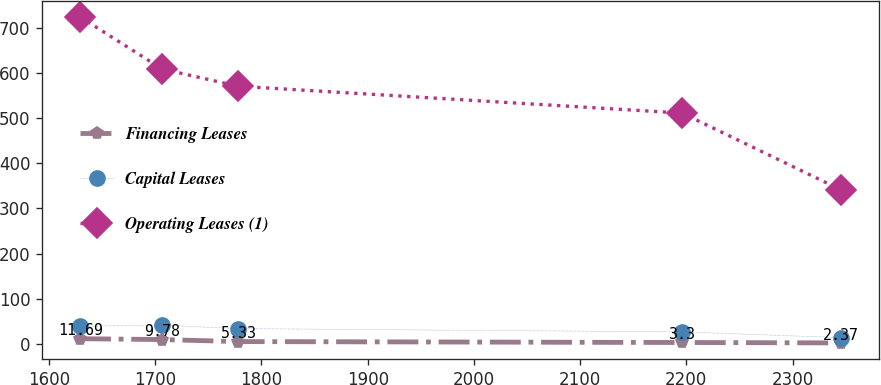Convert chart. <chart><loc_0><loc_0><loc_500><loc_500><line_chart><ecel><fcel>Financing Leases<fcel>Capital Leases<fcel>Operating Leases (1)<nl><fcel>1629.12<fcel>11.69<fcel>39.1<fcel>723.95<nl><fcel>1706.2<fcel>9.78<fcel>41.88<fcel>608.71<nl><fcel>1777.82<fcel>5.33<fcel>34.02<fcel>570.47<nl><fcel>2196.05<fcel>3.3<fcel>26.78<fcel>510.98<nl><fcel>2345.33<fcel>2.37<fcel>14.14<fcel>341.54<nl></chart> 